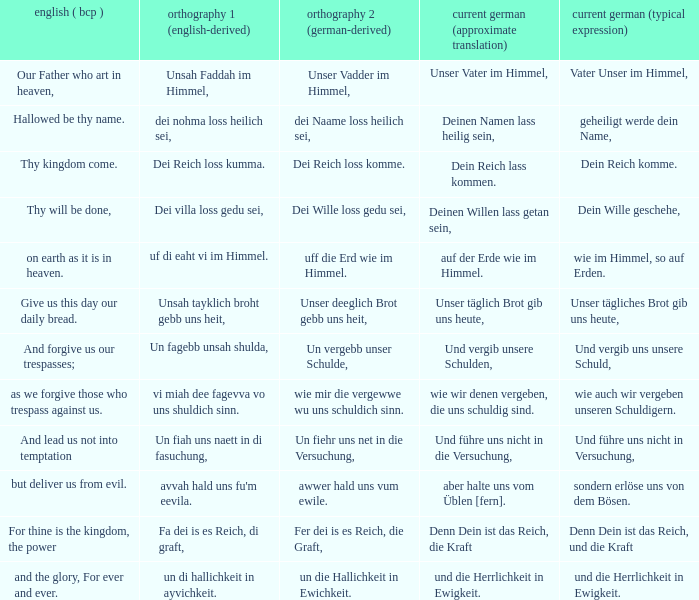What is the modern german standard wording for the german based writing system 2 phrase "wie mir die vergewwe wu uns schuldich sinn."? Wie auch wir vergeben unseren schuldigern. Could you parse the entire table as a dict? {'header': ['english ( bcp )', 'orthography 1 (english-derived)', 'orthography 2 (german-derived)', 'current german (approximate translation)', 'current german (typical expression)'], 'rows': [['Our Father who art in heaven,', 'Unsah Faddah im Himmel,', 'Unser Vadder im Himmel,', 'Unser Vater im Himmel,', 'Vater Unser im Himmel,'], ['Hallowed be thy name.', 'dei nohma loss heilich sei,', 'dei Naame loss heilich sei,', 'Deinen Namen lass heilig sein,', 'geheiligt werde dein Name,'], ['Thy kingdom come.', 'Dei Reich loss kumma.', 'Dei Reich loss komme.', 'Dein Reich lass kommen.', 'Dein Reich komme.'], ['Thy will be done,', 'Dei villa loss gedu sei,', 'Dei Wille loss gedu sei,', 'Deinen Willen lass getan sein,', 'Dein Wille geschehe,'], ['on earth as it is in heaven.', 'uf di eaht vi im Himmel.', 'uff die Erd wie im Himmel.', 'auf der Erde wie im Himmel.', 'wie im Himmel, so auf Erden.'], ['Give us this day our daily bread.', 'Unsah tayklich broht gebb uns heit,', 'Unser deeglich Brot gebb uns heit,', 'Unser täglich Brot gib uns heute,', 'Unser tägliches Brot gib uns heute,'], ['And forgive us our trespasses;', 'Un fagebb unsah shulda,', 'Un vergebb unser Schulde,', 'Und vergib unsere Schulden,', 'Und vergib uns unsere Schuld,'], ['as we forgive those who trespass against us.', 'vi miah dee fagevva vo uns shuldich sinn.', 'wie mir die vergewwe wu uns schuldich sinn.', 'wie wir denen vergeben, die uns schuldig sind.', 'wie auch wir vergeben unseren Schuldigern.'], ['And lead us not into temptation', 'Un fiah uns naett in di fasuchung,', 'Un fiehr uns net in die Versuchung,', 'Und führe uns nicht in die Versuchung,', 'Und führe uns nicht in Versuchung,'], ['but deliver us from evil.', "avvah hald uns fu'm eevila.", 'awwer hald uns vum ewile.', 'aber halte uns vom Üblen [fern].', 'sondern erlöse uns von dem Bösen.'], ['For thine is the kingdom, the power', 'Fa dei is es Reich, di graft,', 'Fer dei is es Reich, die Graft,', 'Denn Dein ist das Reich, die Kraft', 'Denn Dein ist das Reich, und die Kraft'], ['and the glory, For ever and ever.', 'un di hallichkeit in ayvichkeit.', 'un die Hallichkeit in Ewichkeit.', 'und die Herrlichkeit in Ewigkeit.', 'und die Herrlichkeit in Ewigkeit.']]} 